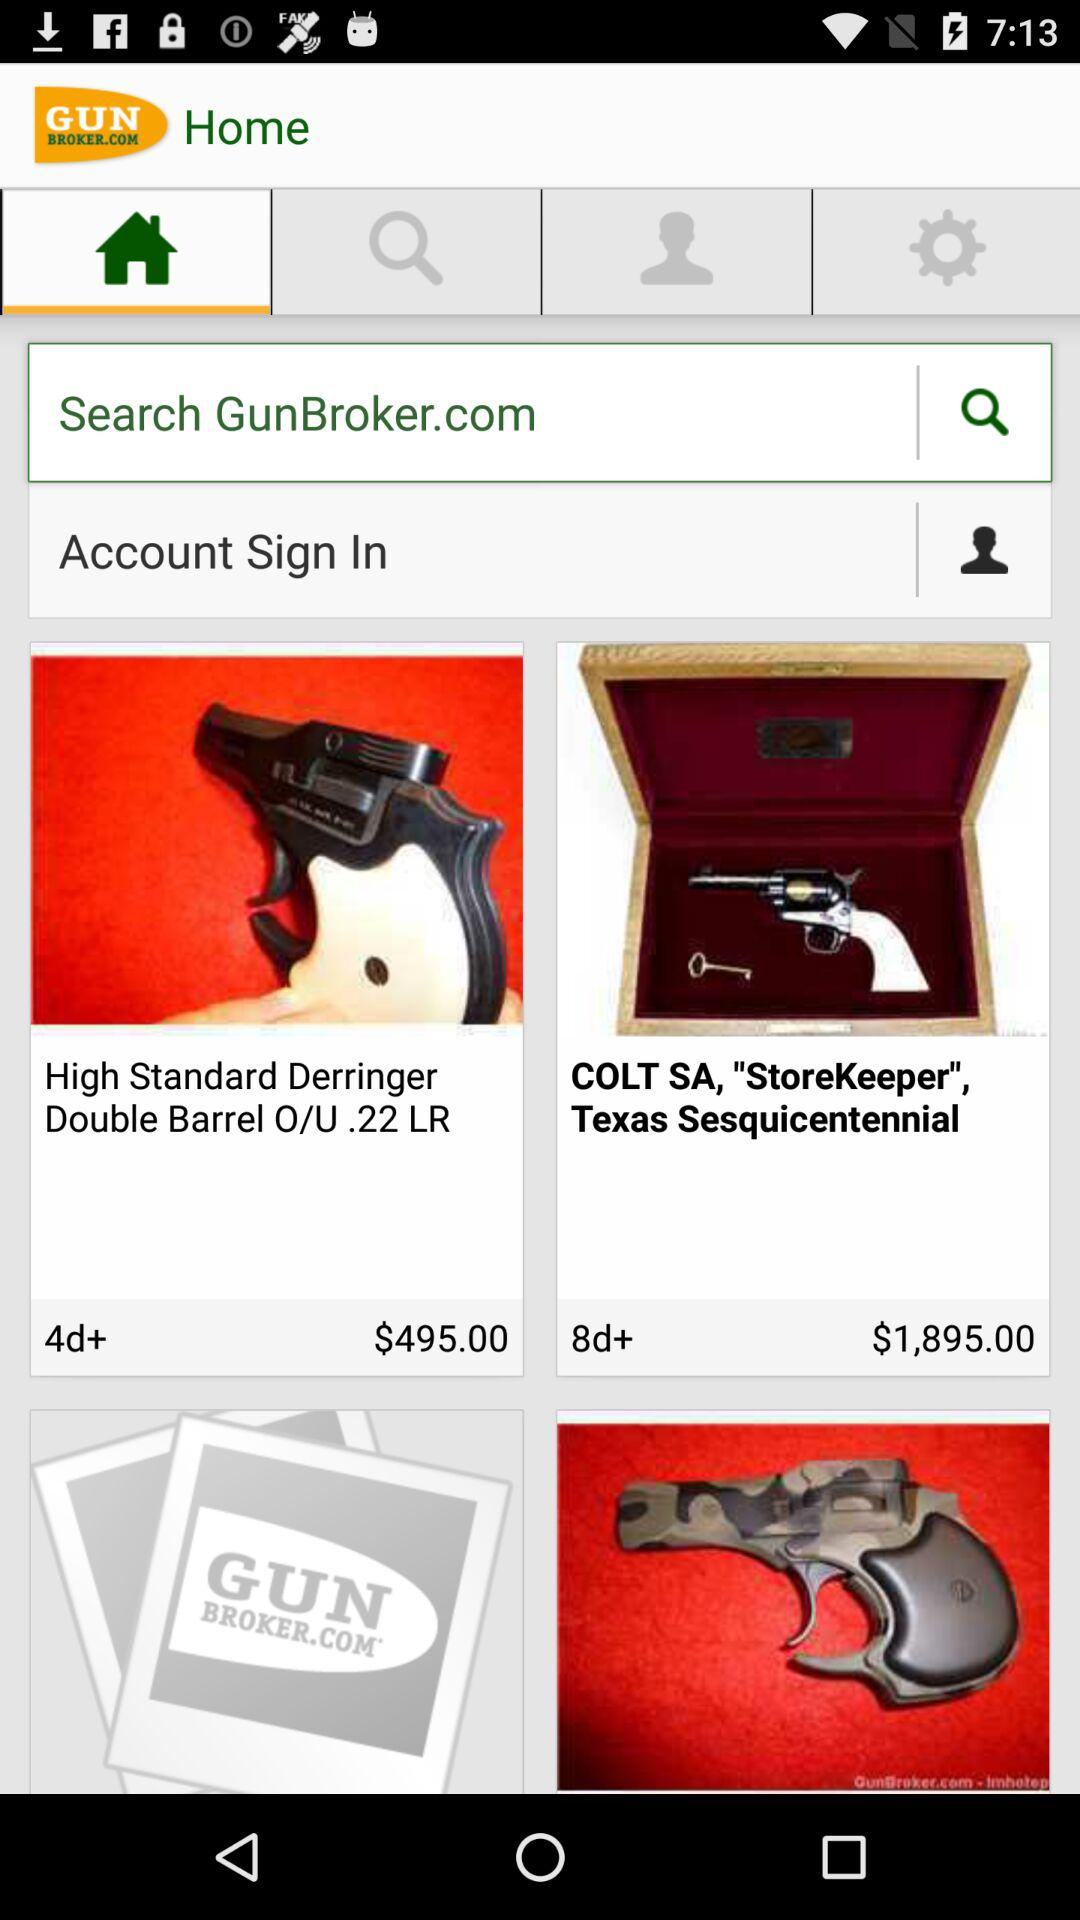What is the cost of the "COLT SA, "Storekeeper", Texas Sesquicentennial"? The cost is $1,895. 